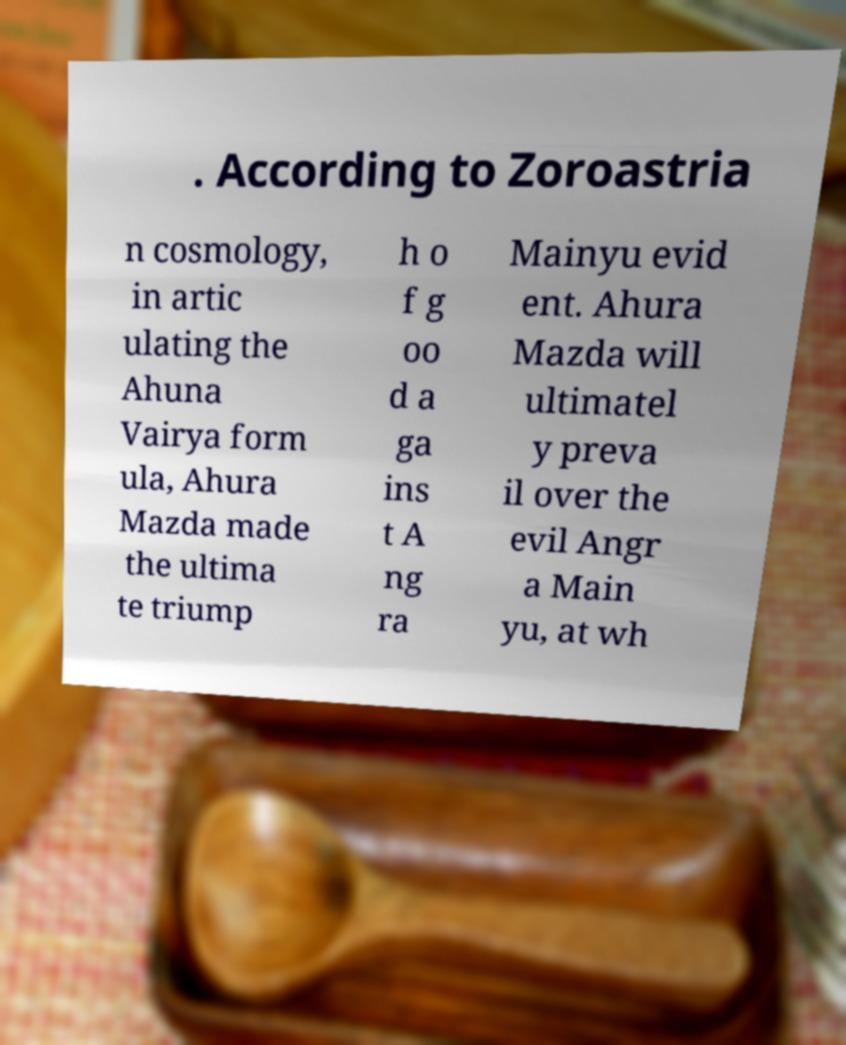There's text embedded in this image that I need extracted. Can you transcribe it verbatim? . According to Zoroastria n cosmology, in artic ulating the Ahuna Vairya form ula, Ahura Mazda made the ultima te triump h o f g oo d a ga ins t A ng ra Mainyu evid ent. Ahura Mazda will ultimatel y preva il over the evil Angr a Main yu, at wh 